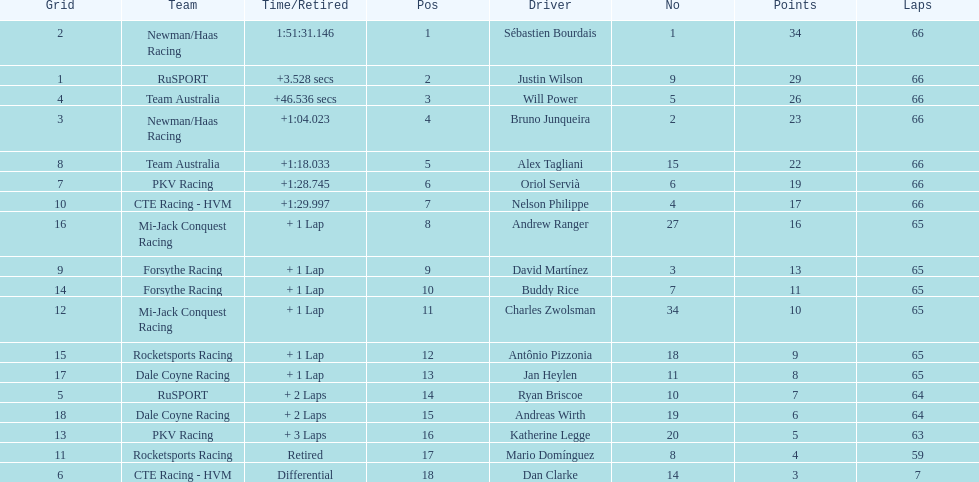At the 2006 gran premio telmex, who scored the highest number of points? Sébastien Bourdais. 